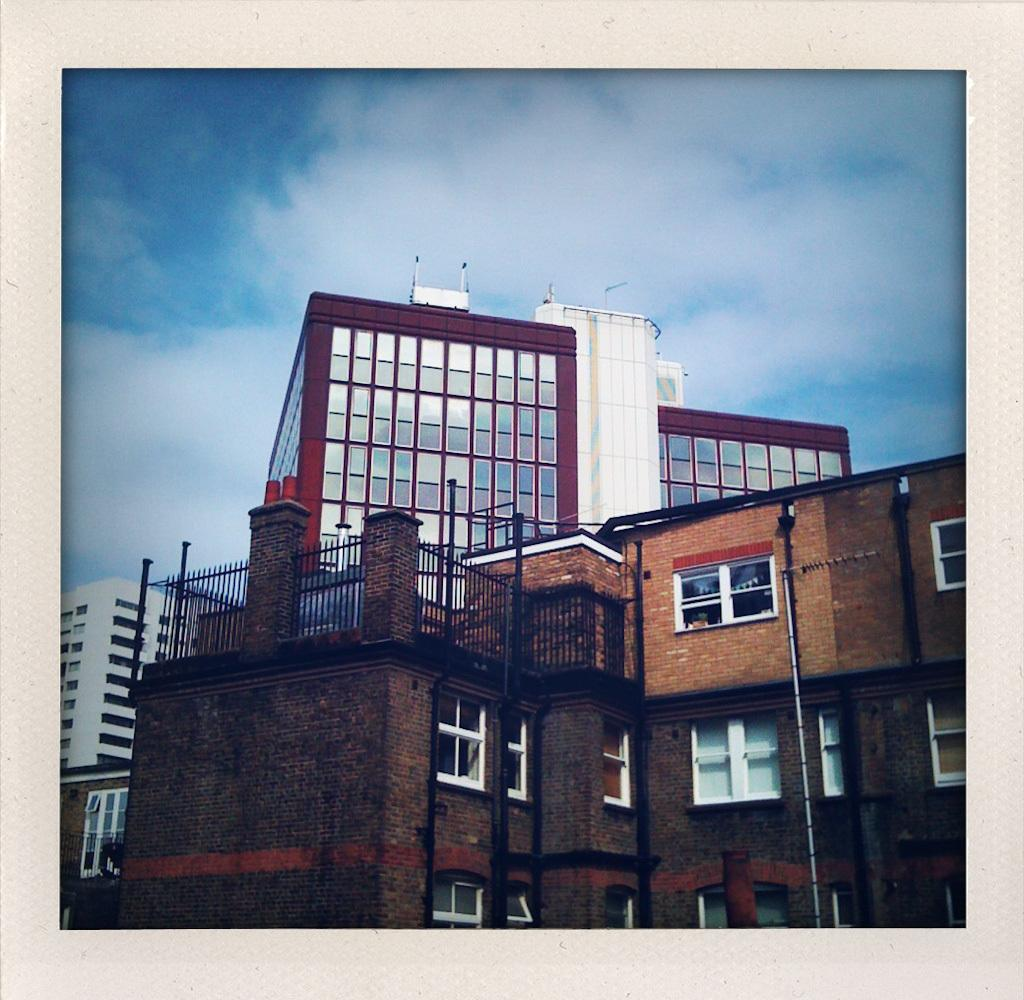What type of structures can be seen in the image? There are buildings in the image. What feature is common to many of the buildings? There are windows in the image. What type of barrier is present in the image? There is a fence in the image. What is visible in the background of the image? The sky is visible in the image. What can be observed in the sky? Clouds are present in the sky. What type of tree can be seen swaying in the wind in the image? There is no tree present in the image, nor is there any indication of wind or movement. 